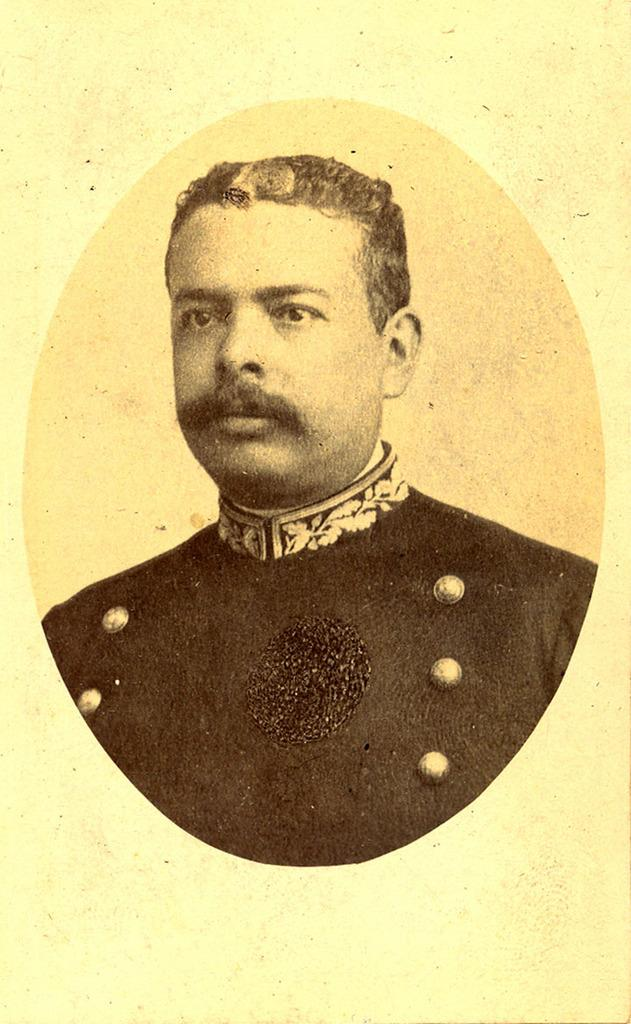Who is present in the image? There is a man in the image. What is the man wearing? The man is wearing a black dress. Are there any mittens in the image? No, there are no mittens present in the image. 